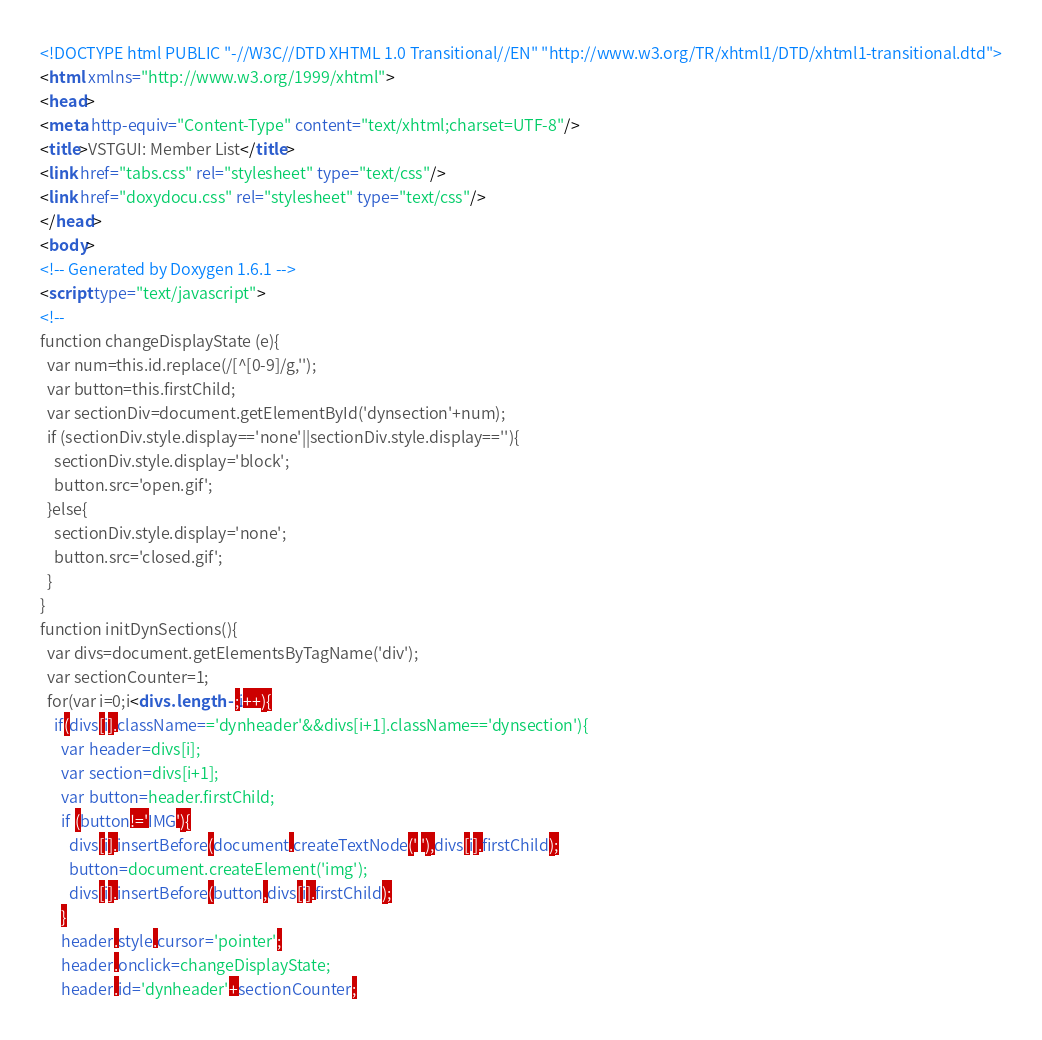Convert code to text. <code><loc_0><loc_0><loc_500><loc_500><_HTML_><!DOCTYPE html PUBLIC "-//W3C//DTD XHTML 1.0 Transitional//EN" "http://www.w3.org/TR/xhtml1/DTD/xhtml1-transitional.dtd">
<html xmlns="http://www.w3.org/1999/xhtml">
<head>
<meta http-equiv="Content-Type" content="text/xhtml;charset=UTF-8"/>
<title>VSTGUI: Member List</title>
<link href="tabs.css" rel="stylesheet" type="text/css"/>
<link href="doxydocu.css" rel="stylesheet" type="text/css"/>
</head>
<body>
<!-- Generated by Doxygen 1.6.1 -->
<script type="text/javascript">
<!--
function changeDisplayState (e){
  var num=this.id.replace(/[^[0-9]/g,'');
  var button=this.firstChild;
  var sectionDiv=document.getElementById('dynsection'+num);
  if (sectionDiv.style.display=='none'||sectionDiv.style.display==''){
    sectionDiv.style.display='block';
    button.src='open.gif';
  }else{
    sectionDiv.style.display='none';
    button.src='closed.gif';
  }
}
function initDynSections(){
  var divs=document.getElementsByTagName('div');
  var sectionCounter=1;
  for(var i=0;i<divs.length-1;i++){
    if(divs[i].className=='dynheader'&&divs[i+1].className=='dynsection'){
      var header=divs[i];
      var section=divs[i+1];
      var button=header.firstChild;
      if (button!='IMG'){
        divs[i].insertBefore(document.createTextNode(' '),divs[i].firstChild);
        button=document.createElement('img');
        divs[i].insertBefore(button,divs[i].firstChild);
      }
      header.style.cursor='pointer';
      header.onclick=changeDisplayState;
      header.id='dynheader'+sectionCounter;</code> 